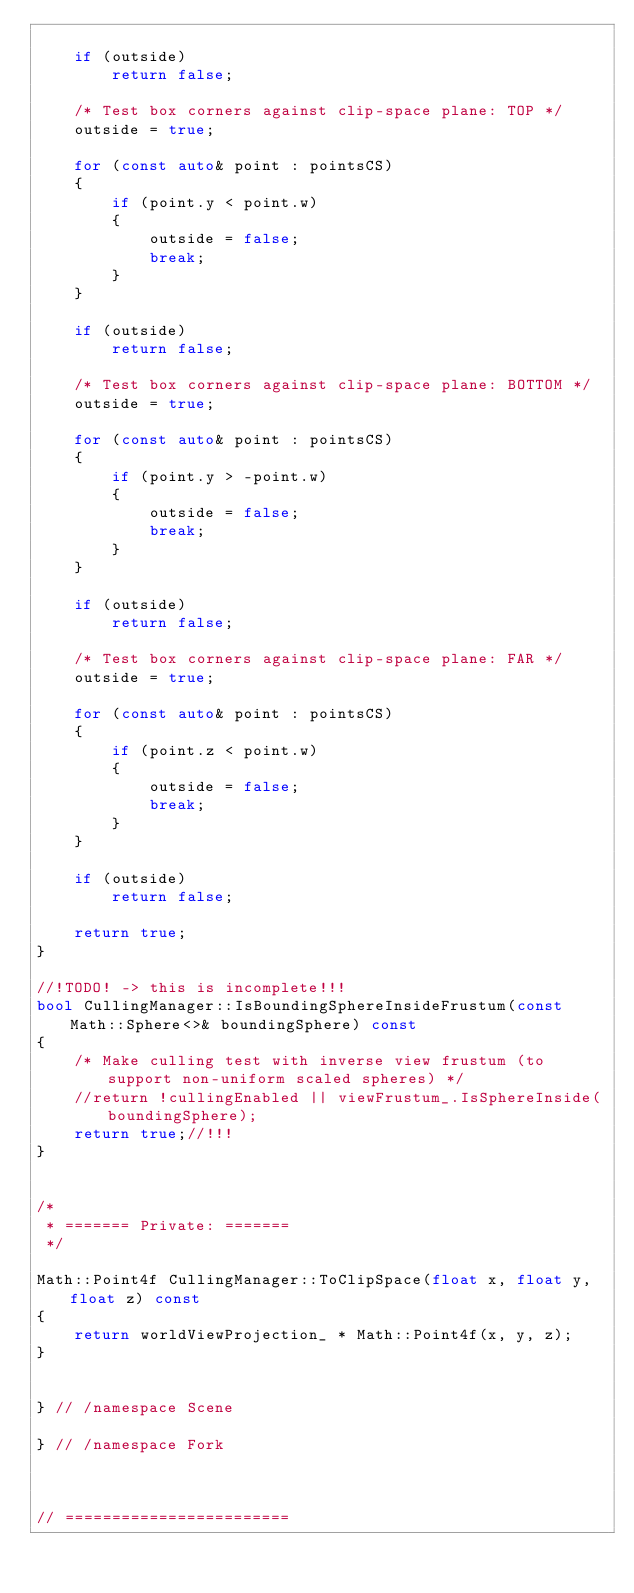Convert code to text. <code><loc_0><loc_0><loc_500><loc_500><_C++_>
    if (outside)
        return false;

    /* Test box corners against clip-space plane: TOP */
    outside = true;

    for (const auto& point : pointsCS)
    {
        if (point.y < point.w)
        {
            outside = false;
            break;
        }
    }

    if (outside)
        return false;

    /* Test box corners against clip-space plane: BOTTOM */
    outside = true;

    for (const auto& point : pointsCS)
    {
        if (point.y > -point.w)
        {
            outside = false;
            break;
        }
    }

    if (outside)
        return false;

    /* Test box corners against clip-space plane: FAR */
    outside = true;

    for (const auto& point : pointsCS)
    {
        if (point.z < point.w)
        {
            outside = false;
            break;
        }
    }

    if (outside)
        return false;

    return true;
}

//!TODO! -> this is incomplete!!!
bool CullingManager::IsBoundingSphereInsideFrustum(const Math::Sphere<>& boundingSphere) const
{
    /* Make culling test with inverse view frustum (to support non-uniform scaled spheres) */
    //return !cullingEnabled || viewFrustum_.IsSphereInside(boundingSphere);
    return true;//!!!
}


/*
 * ======= Private: =======
 */

Math::Point4f CullingManager::ToClipSpace(float x, float y, float z) const
{
    return worldViewProjection_ * Math::Point4f(x, y, z);
}


} // /namespace Scene

} // /namespace Fork



// ========================</code> 